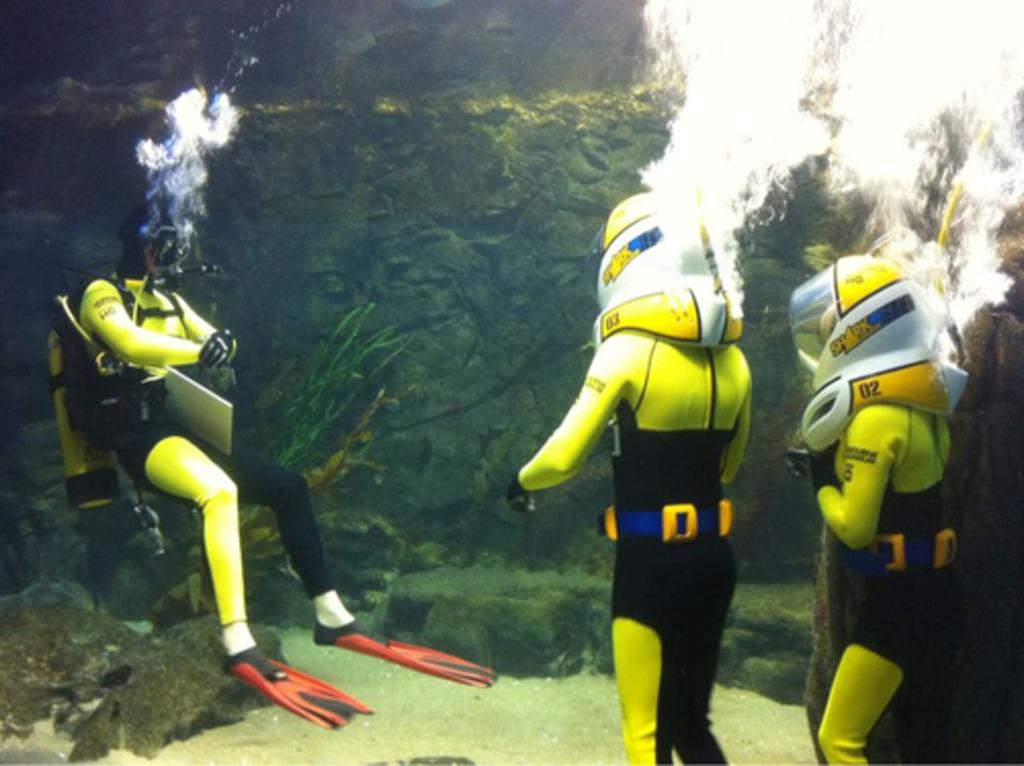Provide a one-sentence caption for the provided image. some deep sea divers, one of whom has the number 3 on their arm. 